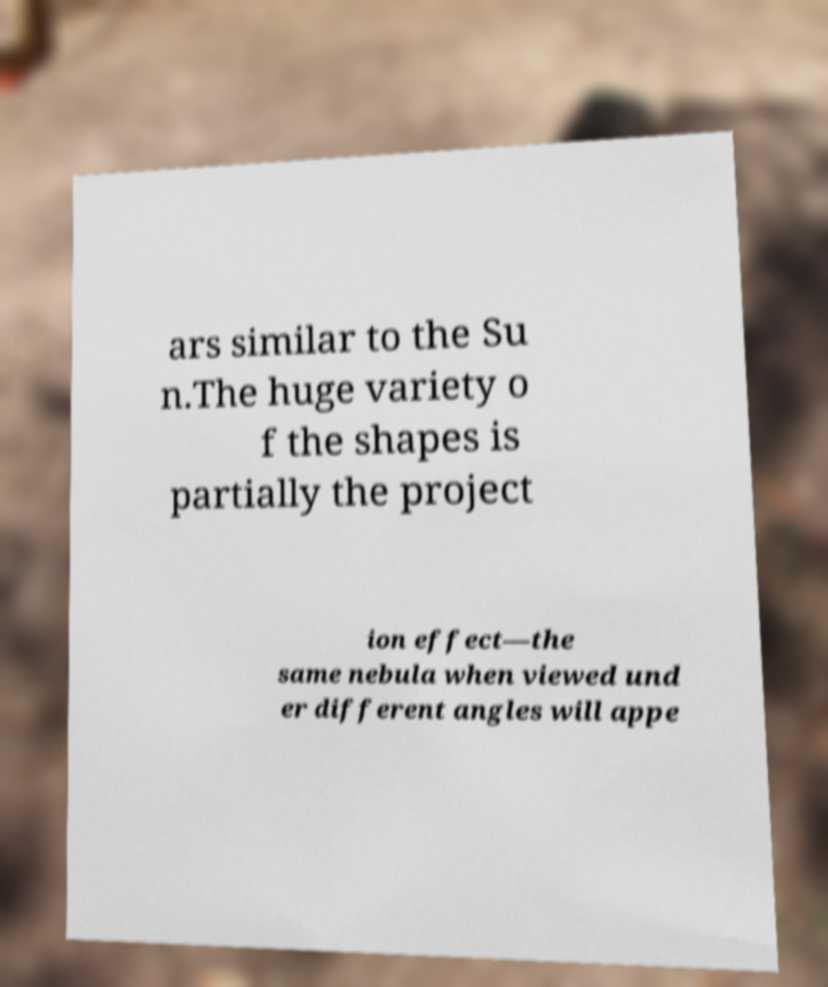Can you read and provide the text displayed in the image?This photo seems to have some interesting text. Can you extract and type it out for me? ars similar to the Su n.The huge variety o f the shapes is partially the project ion effect—the same nebula when viewed und er different angles will appe 